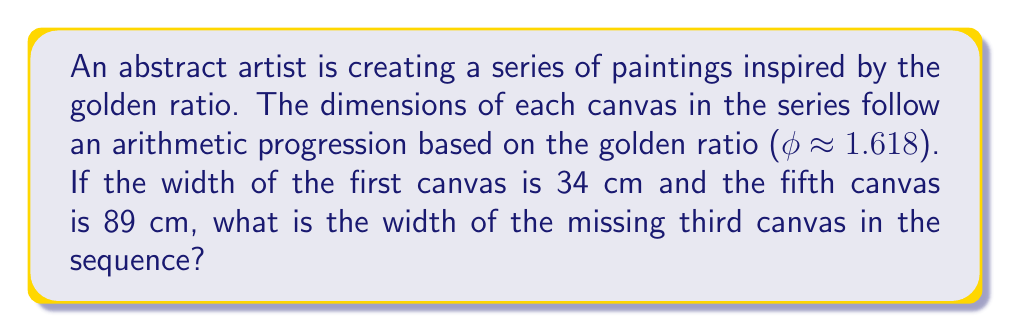Can you solve this math problem? Let's approach this step-by-step:

1) In an arithmetic progression, the difference between each term is constant. Let's call this common difference $d$.

2) We know the first term $a_1 = 34$ and the fifth term $a_5 = 89$.

3) In an arithmetic progression, the nth term is given by:
   $a_n = a_1 + (n-1)d$

4) Using this formula for the fifth term:
   $89 = 34 + (5-1)d$
   $89 = 34 + 4d$
   $55 = 4d$
   $d = 55/4 = 13.75$

5) Now that we know the common difference, we can find the third term:
   $a_3 = a_1 + (3-1)d$
   $a_3 = 34 + 2(13.75)$
   $a_3 = 34 + 27.5 = 61.5$

6) Interestingly, this sequence (34, 47.75, 61.5, 75.25, 89) is closely related to the Fibonacci sequence multiplied by the golden ratio $\phi$:

   $34 \approx 21\phi$
   $47.75 \approx 29\phi$
   $61.5 \approx 38\phi$
   $75.25 \approx 47\phi$
   $89 \approx 55\phi$

   This connection between the arithmetic sequence and the golden ratio in art composition adds an extra layer of aesthetic harmony to the artist's work.
Answer: 61.5 cm 